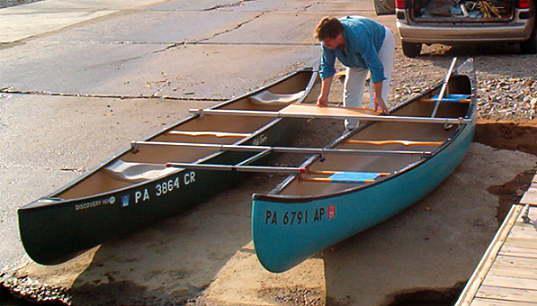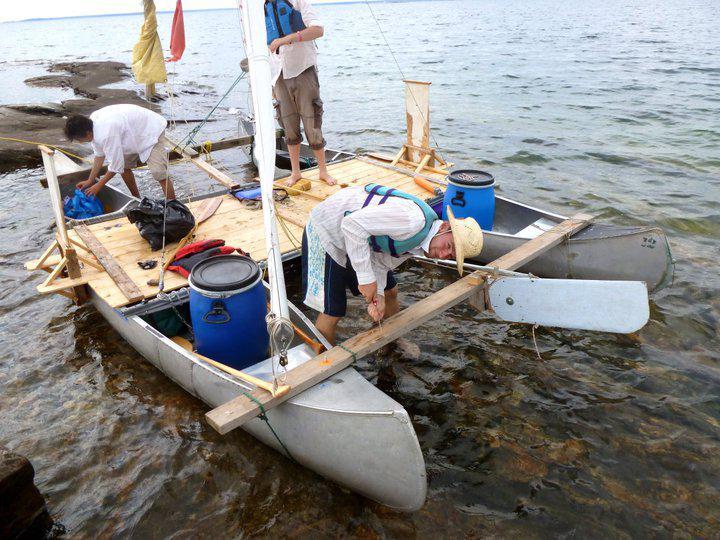The first image is the image on the left, the second image is the image on the right. For the images shown, is this caption "There is three humans in the right image." true? Answer yes or no. Yes. 